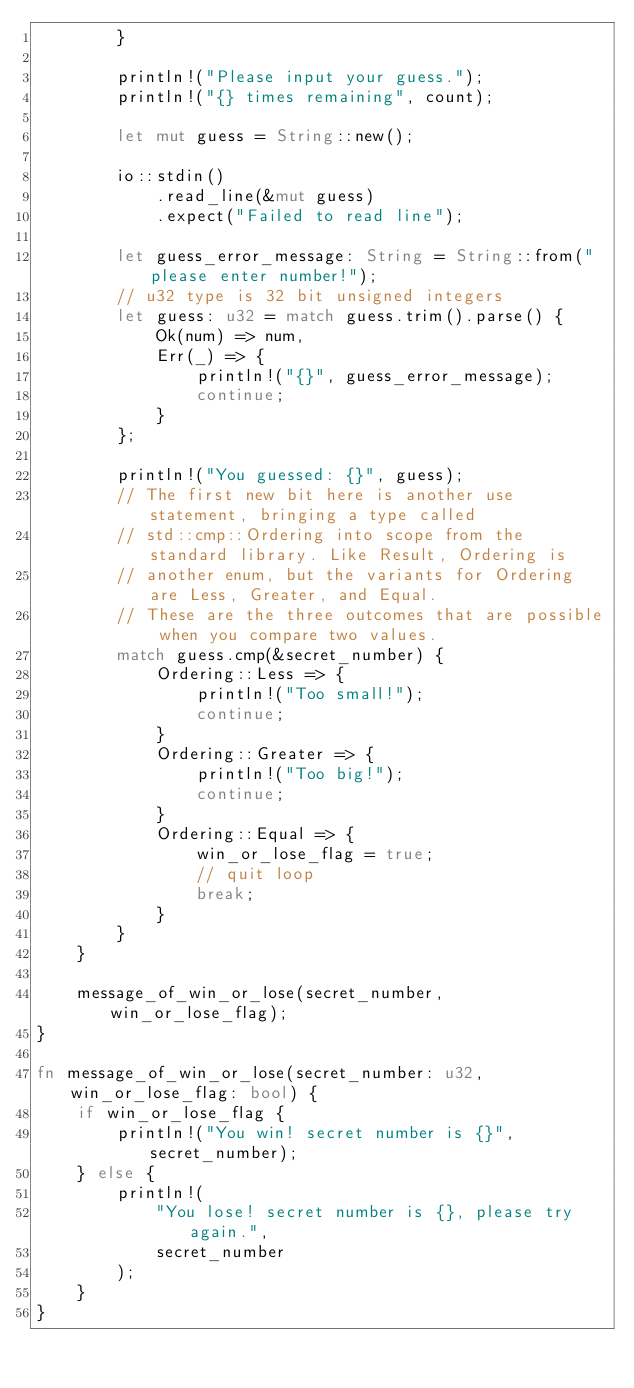<code> <loc_0><loc_0><loc_500><loc_500><_Rust_>        }

        println!("Please input your guess.");
        println!("{} times remaining", count);

        let mut guess = String::new();

        io::stdin()
            .read_line(&mut guess)
            .expect("Failed to read line");

        let guess_error_message: String = String::from("please enter number!");
        // u32 type is 32 bit unsigned integers
        let guess: u32 = match guess.trim().parse() {
            Ok(num) => num,
            Err(_) => {
                println!("{}", guess_error_message);
                continue;
            }
        };

        println!("You guessed: {}", guess);
        // The first new bit here is another use statement, bringing a type called
        // std::cmp::Ordering into scope from the standard library. Like Result, Ordering is
        // another enum, but the variants for Ordering are Less, Greater, and Equal.
        // These are the three outcomes that are possible when you compare two values.
        match guess.cmp(&secret_number) {
            Ordering::Less => {
                println!("Too small!");
                continue;
            }
            Ordering::Greater => {
                println!("Too big!");
                continue;
            }
            Ordering::Equal => {
                win_or_lose_flag = true;
                // quit loop
                break;
            }
        }
    }

    message_of_win_or_lose(secret_number, win_or_lose_flag);
}

fn message_of_win_or_lose(secret_number: u32, win_or_lose_flag: bool) {
    if win_or_lose_flag {
        println!("You win! secret number is {}", secret_number);
    } else {
        println!(
            "You lose! secret number is {}, please try again.",
            secret_number
        );
    }
}
</code> 